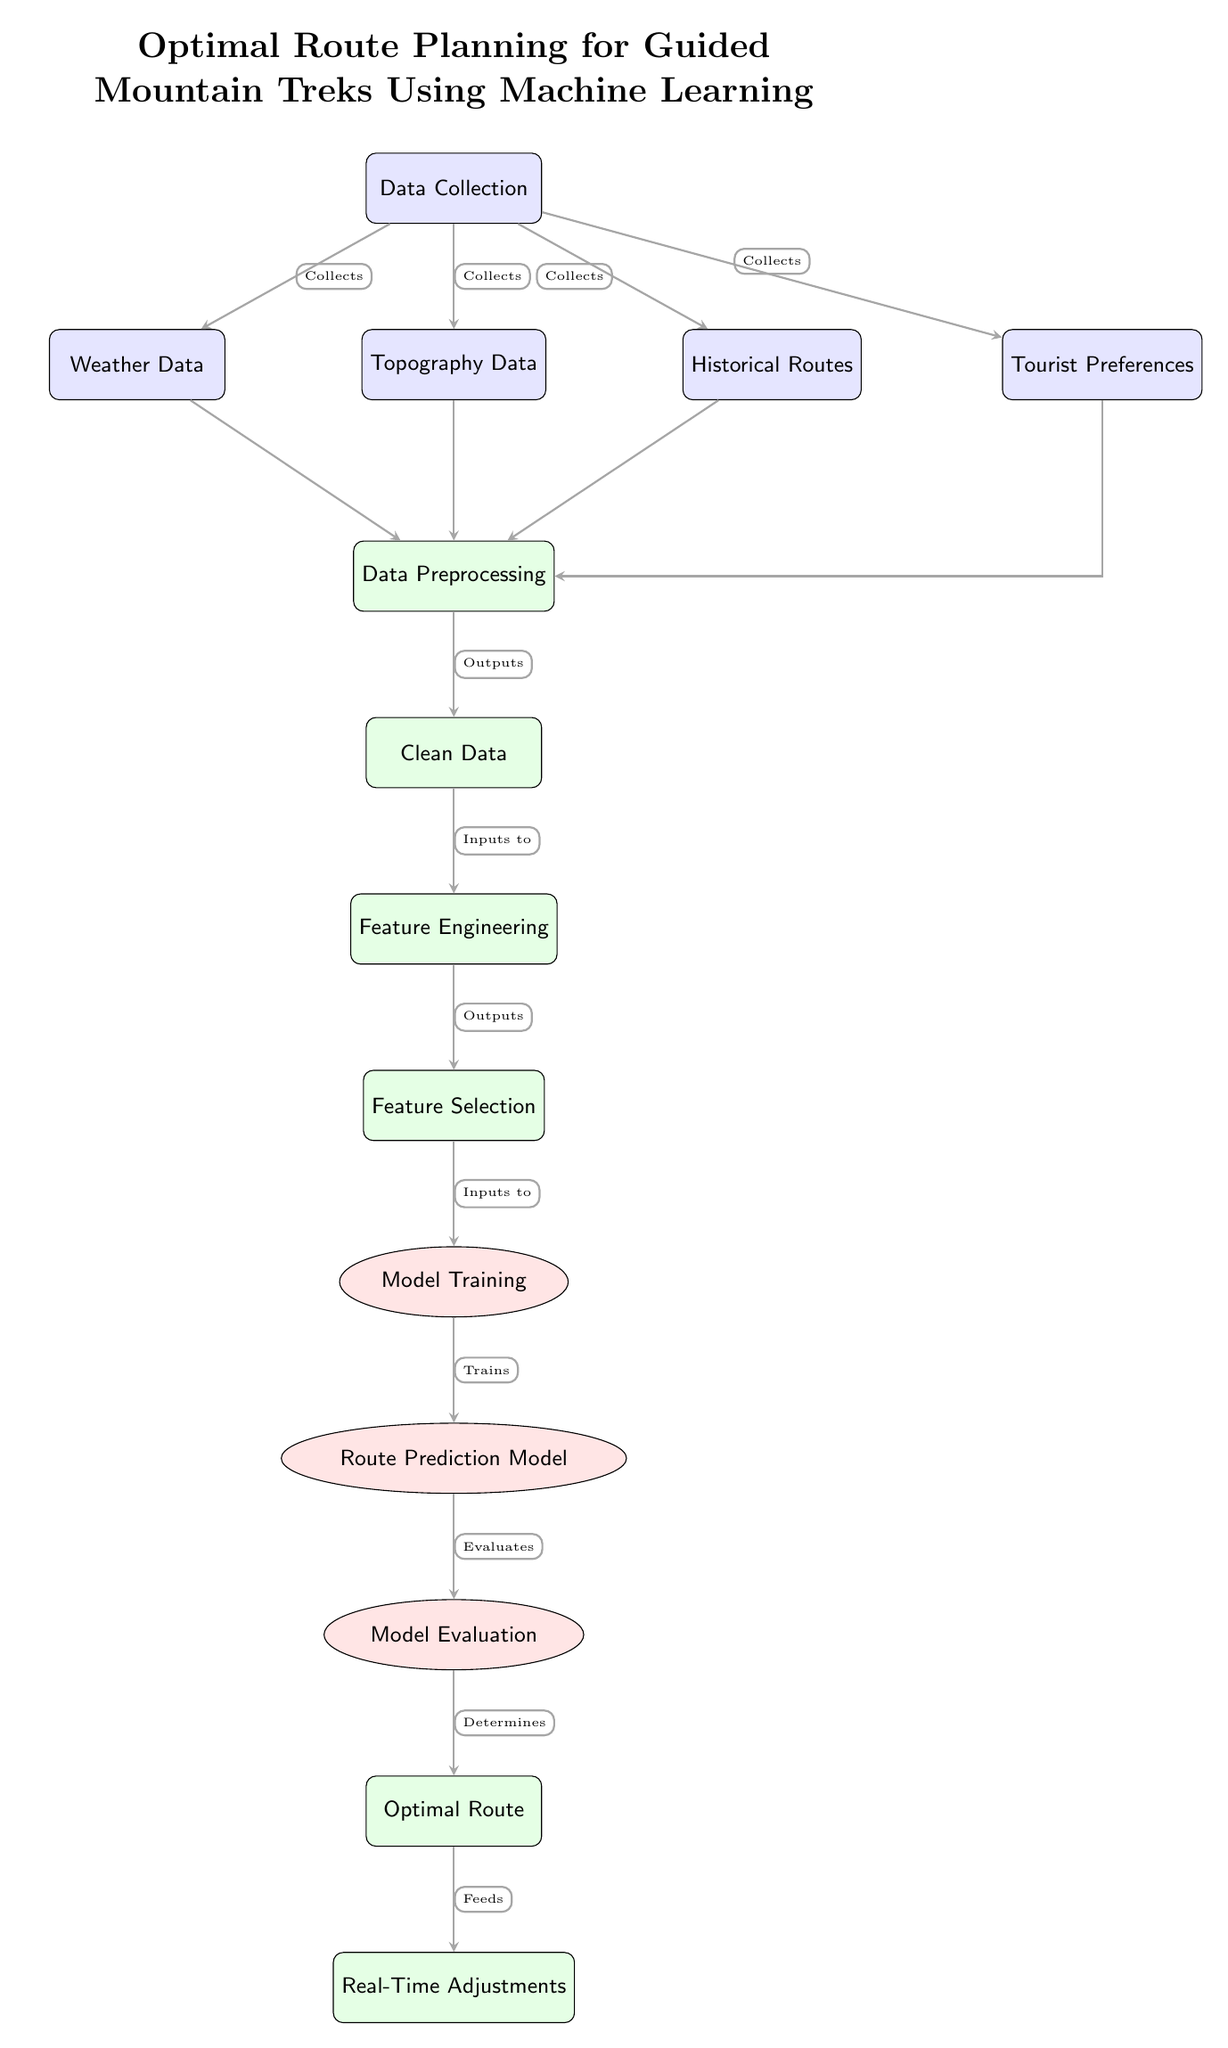What are the four types of data collected at the beginning? The diagram shows four data types collected: Weather Data, Topography Data, Historical Routes, and Tourist Preferences. These nodes branch out from the main Data Collection node.
Answer: Weather Data, Topography Data, Historical Routes, Tourist Preferences What process follows Data Preprocessing? After Data Preprocessing in the diagram, the next step is Clean Data, indicating that cleaning is done post-processing.
Answer: Clean Data How many data sources contribute to the Data Preprocessing step? Four data sources (Weather Data, Topography Data, Historical Routes, and Tourist Preferences) flow into the Data Preprocessing node, indicating their contribution.
Answer: Four What is the final output of the process shown in the diagram? The diagram indicates that the final output of the process is Real-Time Adjustments, which comes after determining the Optimal Route.
Answer: Real-Time Adjustments Which model is trained during the process? The diagram specifically names the Route Prediction Model as the model that is trained during the training phase.
Answer: Route Prediction Model What comes after Model Evaluation in the diagram? Following Model Evaluation, the diagram shows that the step is Optimal Route, indicating that evaluation leads directly to the determination of an optimal path.
Answer: Optimal Route How many processes are illustrated in the diagram? There are seven processes depicted in the diagram, which include Data Preprocessing, Clean Data, Feature Engineering, Feature Selection, Model Training, Model Evaluation, and Optimal Route.
Answer: Seven What type of adjustment is mentioned at the end of the process? The diagram specifies Real-Time Adjustments as the type of adjustment that takes place at the end of the described process.
Answer: Real-Time Adjustments What is the purpose of Feature Selection in the diagram? Feature Selection serves as an intermediate step to reduce the number of features used in Model Training, optimizing the input data.
Answer: Reduce features for training Which data source influences Data Preprocessing through a side connection? The Tourist Preferences data source influences Data Preprocessing not directly but through a side connection, indicating a different flow path.
Answer: Tourist Preferences 